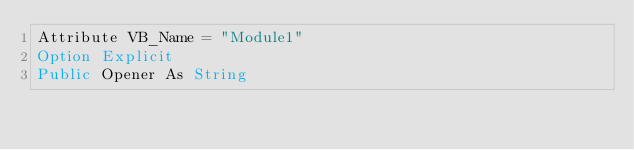<code> <loc_0><loc_0><loc_500><loc_500><_VisualBasic_>Attribute VB_Name = "Module1"
Option Explicit
Public Opener As String</code> 